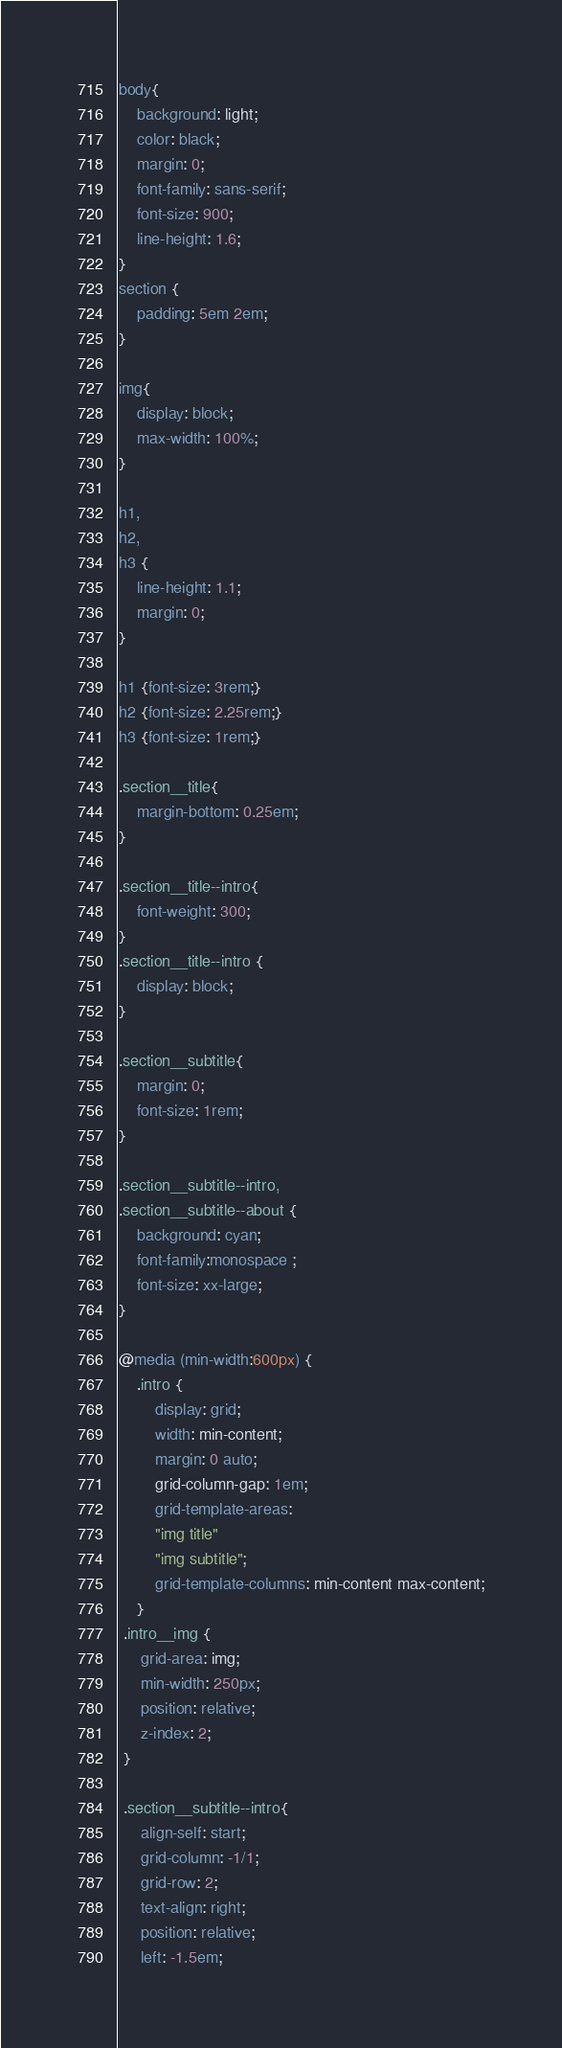Convert code to text. <code><loc_0><loc_0><loc_500><loc_500><_CSS_>body{
    background: light;
    color: black;
    margin: 0;
    font-family: sans-serif;
    font-size: 900;
    line-height: 1.6; 
}
section {
    padding: 5em 2em;
}

img{
    display: block;
    max-width: 100%;
}

h1,
h2,
h3 {
    line-height: 1.1;
    margin: 0;
}

h1 {font-size: 3rem;}
h2 {font-size: 2.25rem;}
h3 {font-size: 1rem;}

.section__title{
    margin-bottom: 0.25em;
}

.section__title--intro{
    font-weight: 300;
}
.section__title--intro {
    display: block;
}

.section__subtitle{
    margin: 0;
    font-size: 1rem;
}

.section__subtitle--intro,
.section__subtitle--about {
    background: cyan;
    font-family:monospace ;
    font-size: xx-large;
}

@media (min-width:600px) {
    .intro {
        display: grid;
        width: min-content;
        margin: 0 auto;
        grid-column-gap: 1em;
        grid-template-areas:
        "img title" 
        "img subtitle";
        grid-template-columns: min-content max-content;
    }
 .intro__img {
     grid-area: img;
     min-width: 250px;
     position: relative;
     z-index: 2;
 }

 .section__subtitle--intro{
     align-self: start;
     grid-column: -1/1;
     grid-row: 2;
     text-align: right;
     position: relative;
     left: -1.5em;</code> 